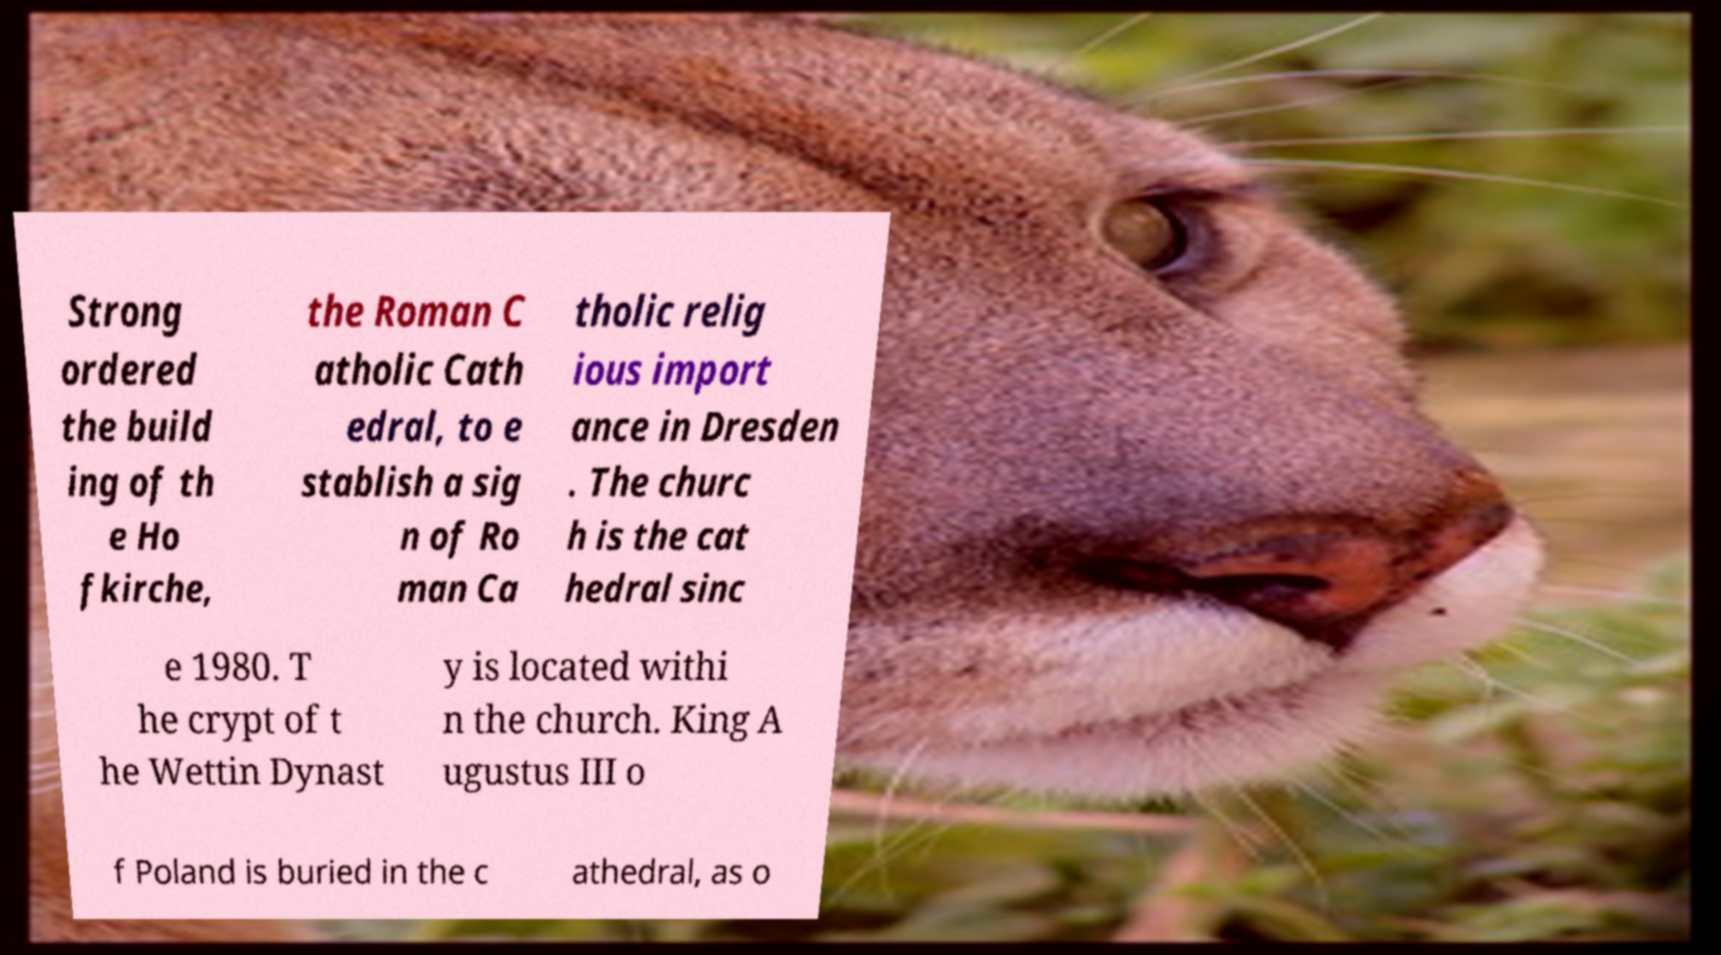I need the written content from this picture converted into text. Can you do that? Strong ordered the build ing of th e Ho fkirche, the Roman C atholic Cath edral, to e stablish a sig n of Ro man Ca tholic relig ious import ance in Dresden . The churc h is the cat hedral sinc e 1980. T he crypt of t he Wettin Dynast y is located withi n the church. King A ugustus III o f Poland is buried in the c athedral, as o 